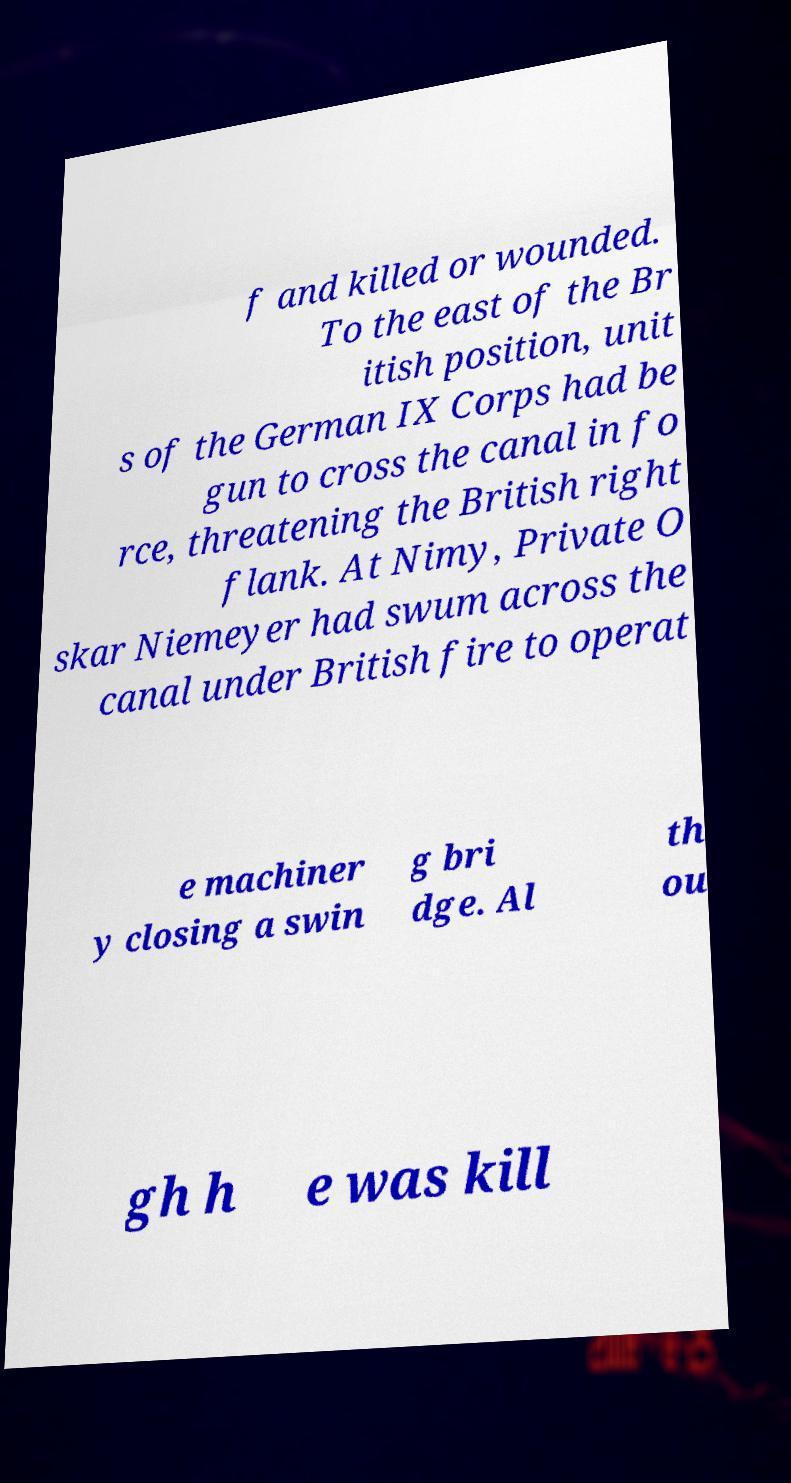Can you read and provide the text displayed in the image?This photo seems to have some interesting text. Can you extract and type it out for me? f and killed or wounded. To the east of the Br itish position, unit s of the German IX Corps had be gun to cross the canal in fo rce, threatening the British right flank. At Nimy, Private O skar Niemeyer had swum across the canal under British fire to operat e machiner y closing a swin g bri dge. Al th ou gh h e was kill 